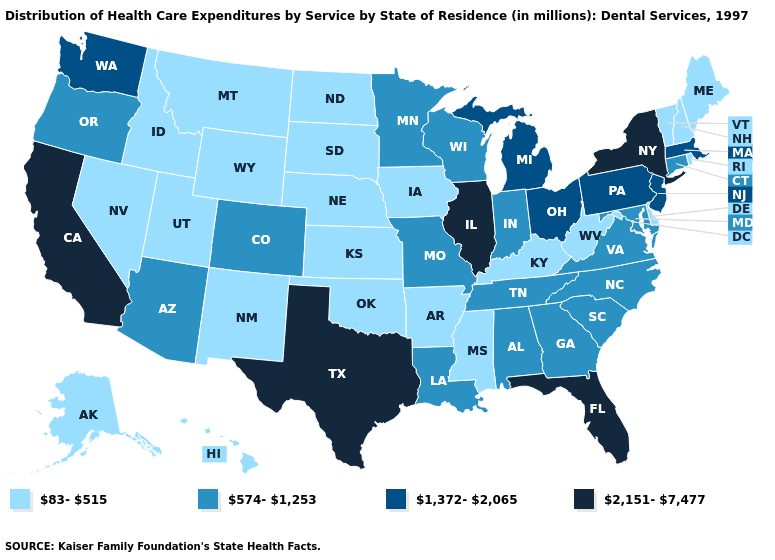What is the highest value in the South ?
Concise answer only. 2,151-7,477. Does the first symbol in the legend represent the smallest category?
Concise answer only. Yes. Which states have the lowest value in the MidWest?
Concise answer only. Iowa, Kansas, Nebraska, North Dakota, South Dakota. Name the states that have a value in the range 1,372-2,065?
Answer briefly. Massachusetts, Michigan, New Jersey, Ohio, Pennsylvania, Washington. Among the states that border New Jersey , does Delaware have the highest value?
Answer briefly. No. Name the states that have a value in the range 2,151-7,477?
Short answer required. California, Florida, Illinois, New York, Texas. Among the states that border Indiana , which have the lowest value?
Quick response, please. Kentucky. Does New York have the same value as Illinois?
Concise answer only. Yes. What is the highest value in the Northeast ?
Give a very brief answer. 2,151-7,477. Name the states that have a value in the range 1,372-2,065?
Be succinct. Massachusetts, Michigan, New Jersey, Ohio, Pennsylvania, Washington. What is the value of Georgia?
Concise answer only. 574-1,253. What is the value of Wisconsin?
Answer briefly. 574-1,253. Name the states that have a value in the range 1,372-2,065?
Short answer required. Massachusetts, Michigan, New Jersey, Ohio, Pennsylvania, Washington. Does Connecticut have the lowest value in the Northeast?
Write a very short answer. No. Among the states that border Illinois , which have the highest value?
Keep it brief. Indiana, Missouri, Wisconsin. 